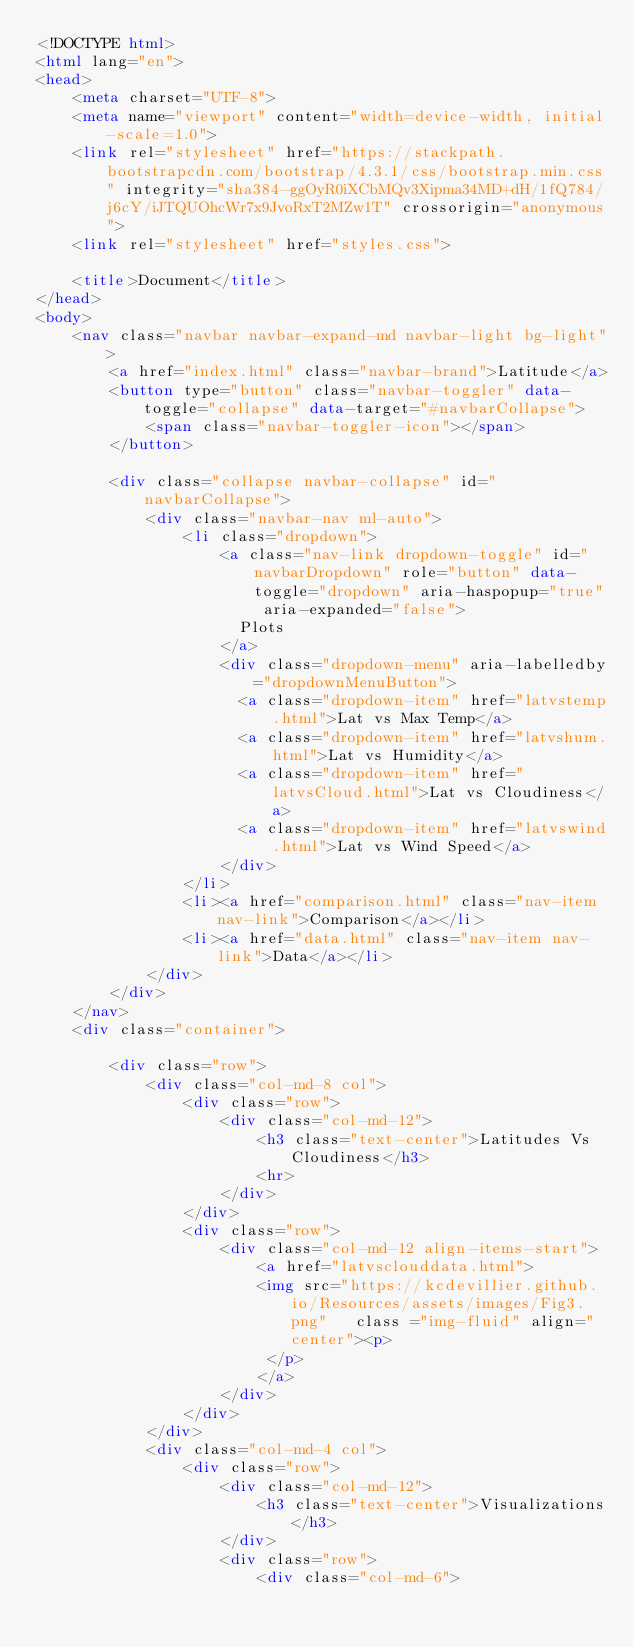Convert code to text. <code><loc_0><loc_0><loc_500><loc_500><_HTML_><!DOCTYPE html>
<html lang="en">
<head>
    <meta charset="UTF-8">
    <meta name="viewport" content="width=device-width, initial-scale=1.0">
    <link rel="stylesheet" href="https://stackpath.bootstrapcdn.com/bootstrap/4.3.1/css/bootstrap.min.css" integrity="sha384-ggOyR0iXCbMQv3Xipma34MD+dH/1fQ784/j6cY/iJTQUOhcWr7x9JvoRxT2MZw1T" crossorigin="anonymous">
    <link rel="stylesheet" href="styles.css">

    <title>Document</title>
</head>
<body>
    <nav class="navbar navbar-expand-md navbar-light bg-light">
        <a href="index.html" class="navbar-brand">Latitude</a>
        <button type="button" class="navbar-toggler" data-toggle="collapse" data-target="#navbarCollapse">
            <span class="navbar-toggler-icon"></span>
        </button>
    
        <div class="collapse navbar-collapse" id="navbarCollapse">
            <div class="navbar-nav ml-auto">
                <li class="dropdown">
                    <a class="nav-link dropdown-toggle" id="navbarDropdown" role="button" data-toggle="dropdown" aria-haspopup="true" aria-expanded="false">
                      Plots
                    </a>
                    <div class="dropdown-menu" aria-labelledby="dropdownMenuButton">
                      <a class="dropdown-item" href="latvstemp.html">Lat vs Max Temp</a>
                      <a class="dropdown-item" href="latvshum.html">Lat vs Humidity</a>
                      <a class="dropdown-item" href="latvsCloud.html">Lat vs Cloudiness</a>
                      <a class="dropdown-item" href="latvswind.html">Lat vs Wind Speed</a>
                    </div>
                </li>
                <li><a href="comparison.html" class="nav-item nav-link">Comparison</a></li>
                <li><a href="data.html" class="nav-item nav-link">Data</a></li>
            </div>
        </div>
    </nav>
    <div class="container"> 

        <div class="row">
            <div class="col-md-8 col">
                <div class="row">
                    <div class="col-md-12">
                        <h3 class="text-center">Latitudes Vs Cloudiness</h3>
                        <hr>
                    </div>
                </div>
                <div class="row">
                    <div class="col-md-12 align-items-start">
                        <a href="latvsclouddata.html">
                        <img src="https://kcdevillier.github.io/Resources/assets/images/Fig3.png"   class ="img-fluid" align="center"><p>
                         </p>
                        </a>
                    </div>
                </div> 
            </div>
            <div class="col-md-4 col">
                <div class="row">
                    <div class="col-md-12">
                        <h3 class="text-center">Visualizations</h3>
                    </div>
                    <div class="row">
                        <div class="col-md-6"></code> 